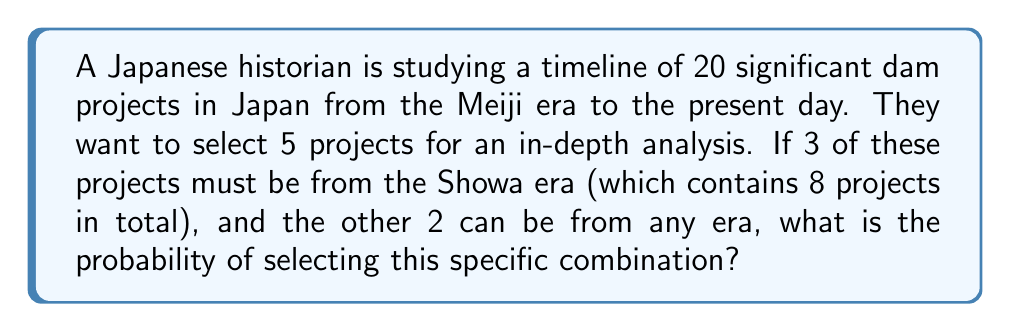Provide a solution to this math problem. Let's approach this step-by-step:

1) First, we need to calculate the number of ways to select 3 projects from the Showa era:
   $$\binom{8}{3} = \frac{8!}{3!(8-3)!} = \frac{8!}{3!5!} = 56$$

2) Next, we need to calculate the number of ways to select the remaining 2 projects from the other 17 projects (20 total - 3 already selected):
   $$\binom{17}{2} = \frac{17!}{2!(17-2)!} = \frac{17!}{2!15!} = 136$$

3) The total number of favorable outcomes is the product of these two combinations:
   $$56 \times 136 = 7,616$$

4) Now, we need to calculate the total number of ways to select 5 projects out of 20:
   $$\binom{20}{5} = \frac{20!}{5!(20-5)!} = \frac{20!}{5!15!} = 15,504$$

5) The probability is the number of favorable outcomes divided by the total number of possible outcomes:

   $$P(\text{3 from Showa, 2 from any era}) = \frac{7,616}{15,504} = \frac{476}{969} \approx 0.4911$$
Answer: $\frac{476}{969}$ or approximately $0.4911$ or $49.11\%$ 